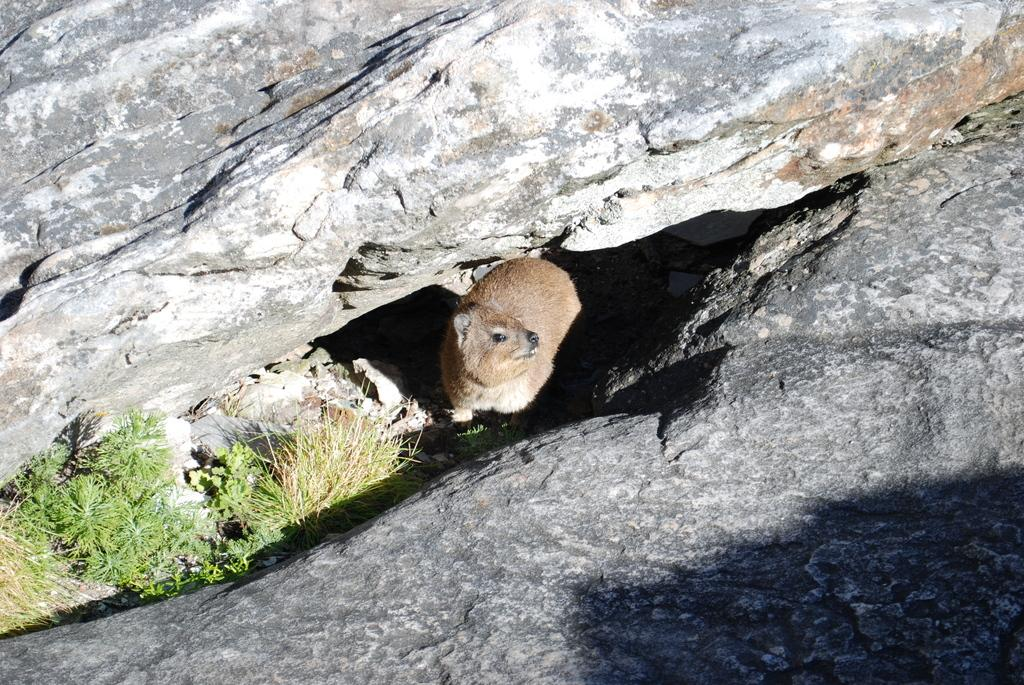What type of creature is present in the image? There is an animal in the image. Can you describe the animal's surroundings? The animal is between rocks. What type of vegetation can be seen in the image? There is grass visible in the image. What type of punishment is the animal receiving in the image? There is no indication of punishment in the image; the animal is simply between rocks. What type of tools might a carpenter use in the image? There are no carpentry tools or a carpenter present in the image. 